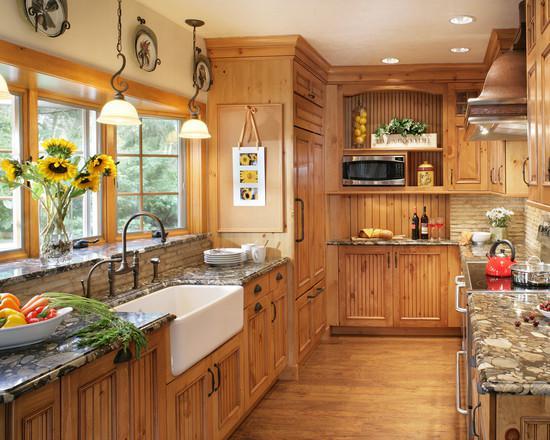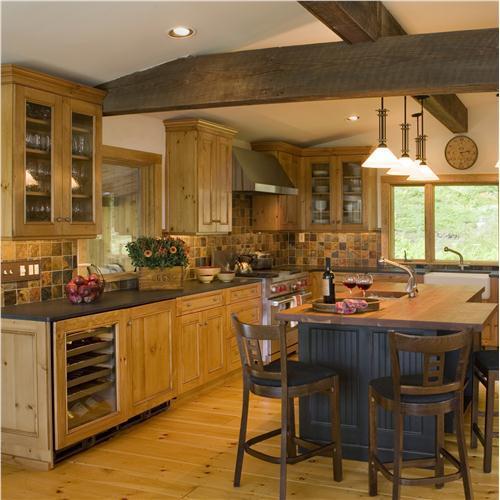The first image is the image on the left, the second image is the image on the right. Considering the images on both sides, is "Right image shows a bay window over a double sink in a white kitchen." valid? Answer yes or no. No. 